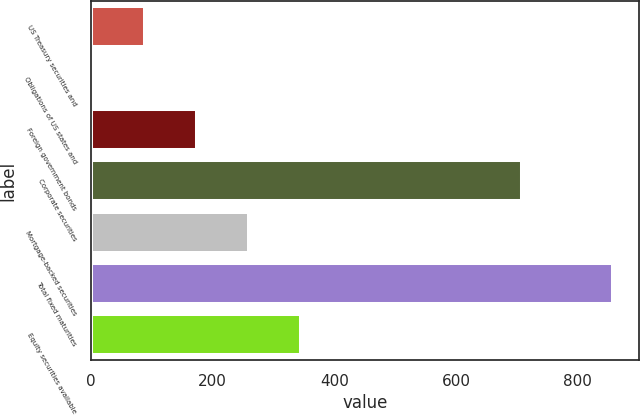Convert chart. <chart><loc_0><loc_0><loc_500><loc_500><bar_chart><fcel>US Treasury securities and<fcel>Obligations of US states and<fcel>Foreign government bonds<fcel>Corporate securities<fcel>Mortgage-backed securities<fcel>Total fixed maturities<fcel>Equity securities available<nl><fcel>88.5<fcel>3<fcel>174<fcel>709<fcel>259.5<fcel>858<fcel>345<nl></chart> 